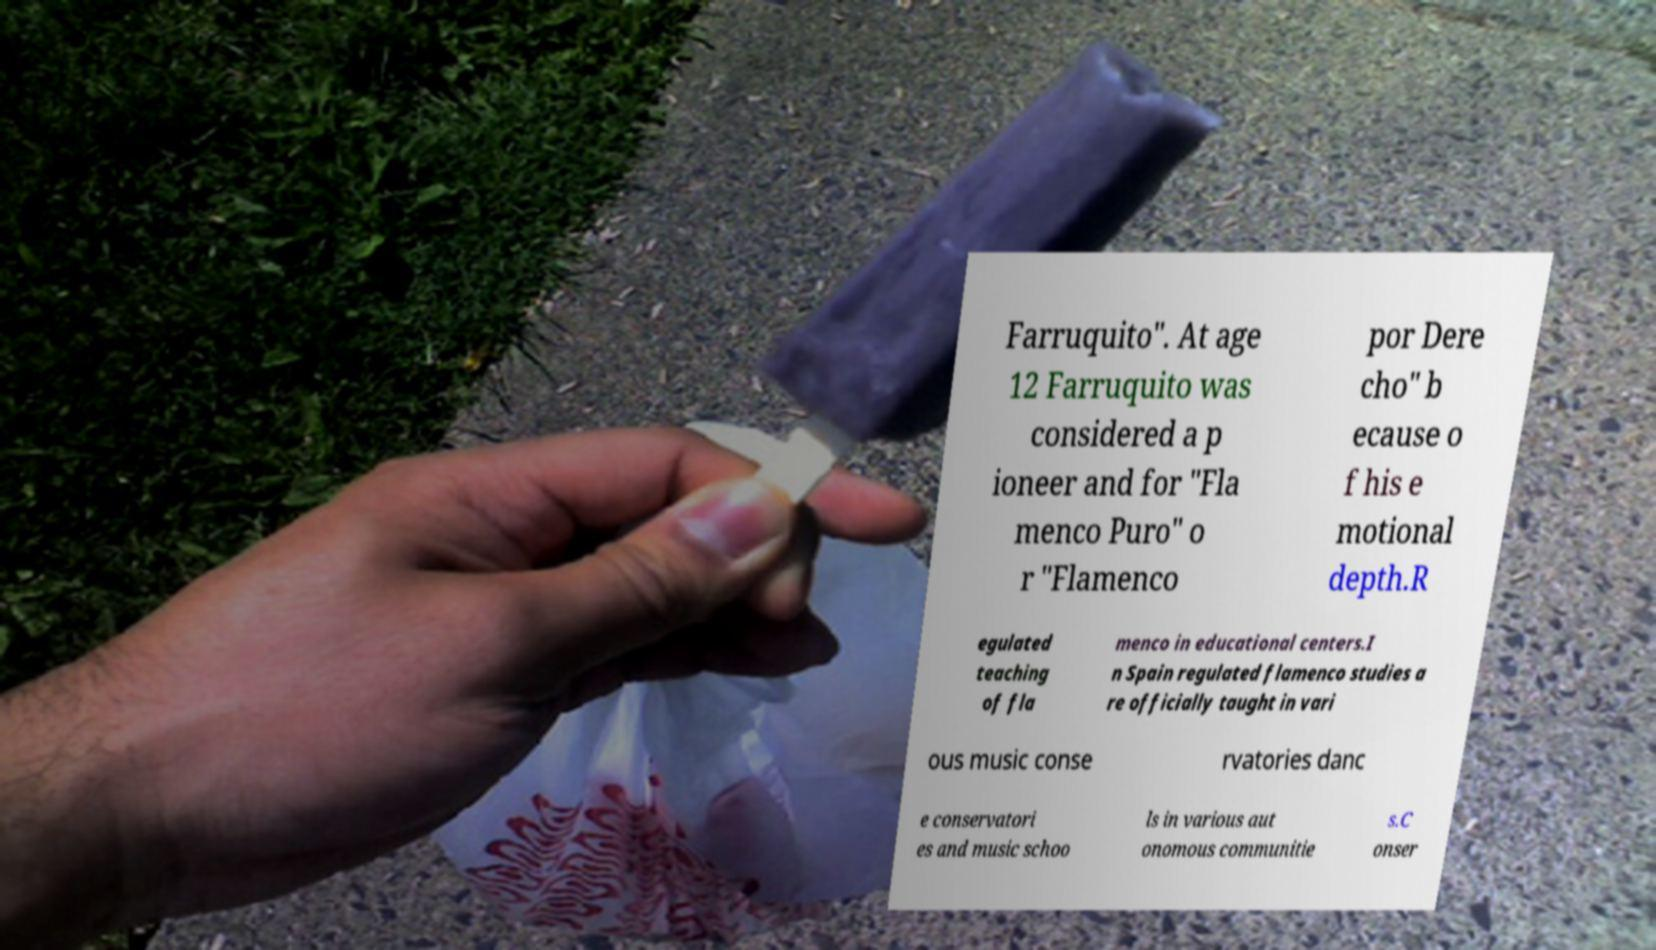Can you read and provide the text displayed in the image?This photo seems to have some interesting text. Can you extract and type it out for me? Farruquito". At age 12 Farruquito was considered a p ioneer and for "Fla menco Puro" o r "Flamenco por Dere cho" b ecause o f his e motional depth.R egulated teaching of fla menco in educational centers.I n Spain regulated flamenco studies a re officially taught in vari ous music conse rvatories danc e conservatori es and music schoo ls in various aut onomous communitie s.C onser 